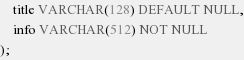Convert code to text. <code><loc_0><loc_0><loc_500><loc_500><_SQL_>    title VARCHAR(128) DEFAULT NULL,
    info VARCHAR(512) NOT NULL
);
</code> 